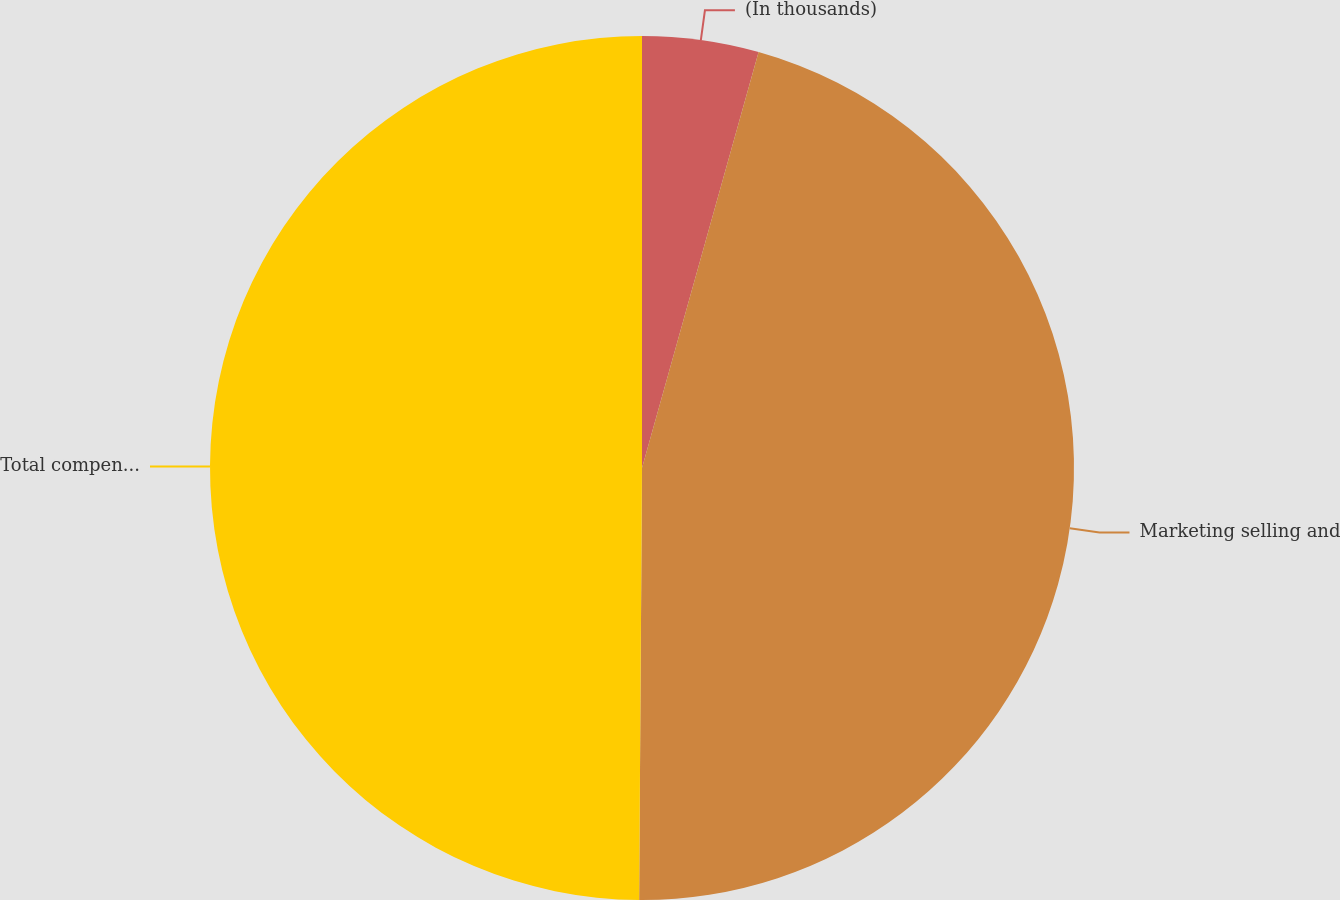Convert chart. <chart><loc_0><loc_0><loc_500><loc_500><pie_chart><fcel>(In thousands)<fcel>Marketing selling and<fcel>Total compensation expense<nl><fcel>4.35%<fcel>45.76%<fcel>49.9%<nl></chart> 